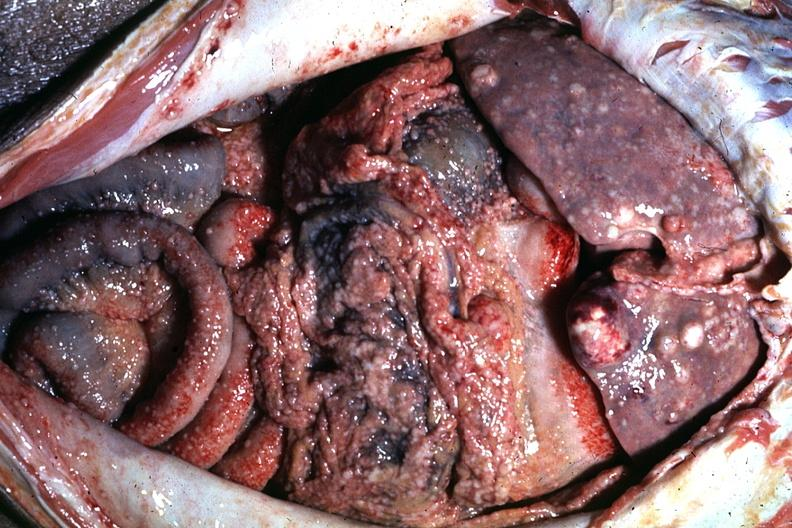what is present?
Answer the question using a single word or phrase. Abdomen 